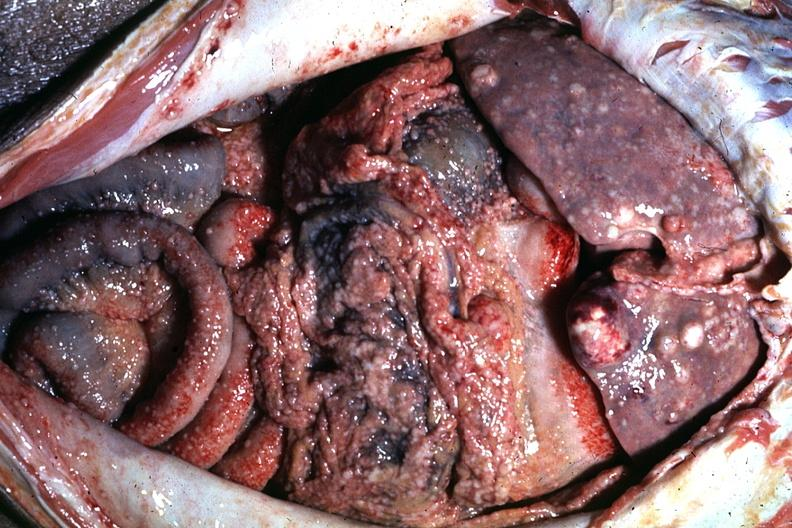what is present?
Answer the question using a single word or phrase. Abdomen 